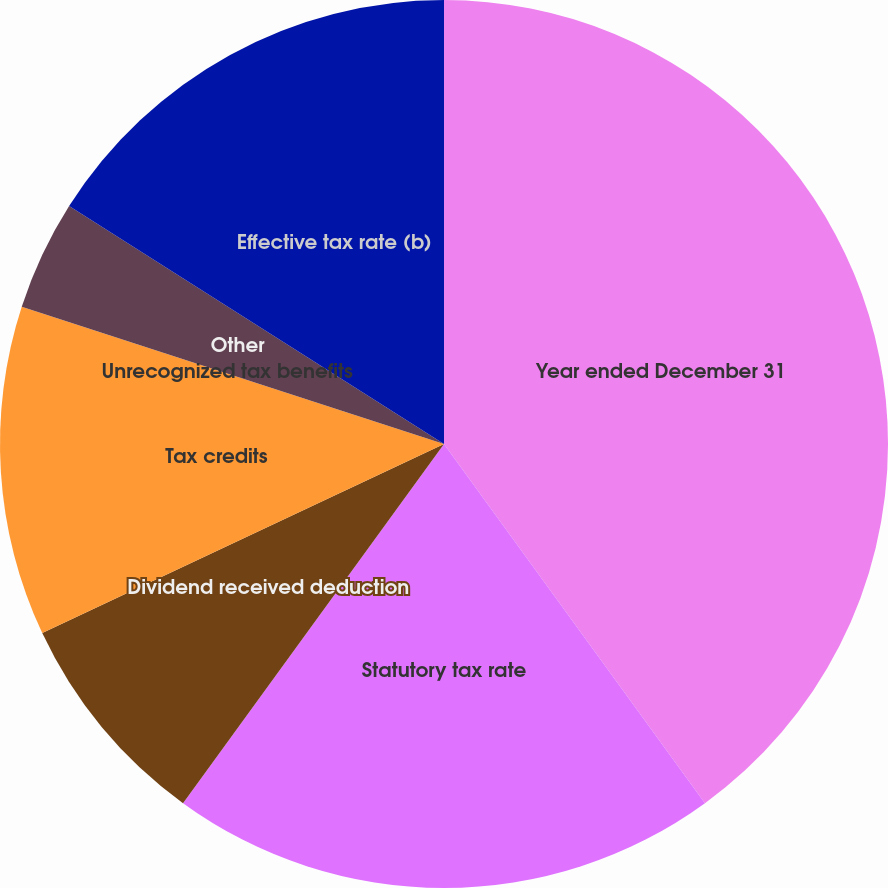Convert chart to OTSL. <chart><loc_0><loc_0><loc_500><loc_500><pie_chart><fcel>Year ended December 31<fcel>Statutory tax rate<fcel>Dividend received deduction<fcel>Tax credits<fcel>Unrecognized tax benefits<fcel>Other<fcel>Effective tax rate (b)<nl><fcel>40.0%<fcel>20.0%<fcel>8.0%<fcel>12.0%<fcel>0.0%<fcel>4.0%<fcel>16.0%<nl></chart> 